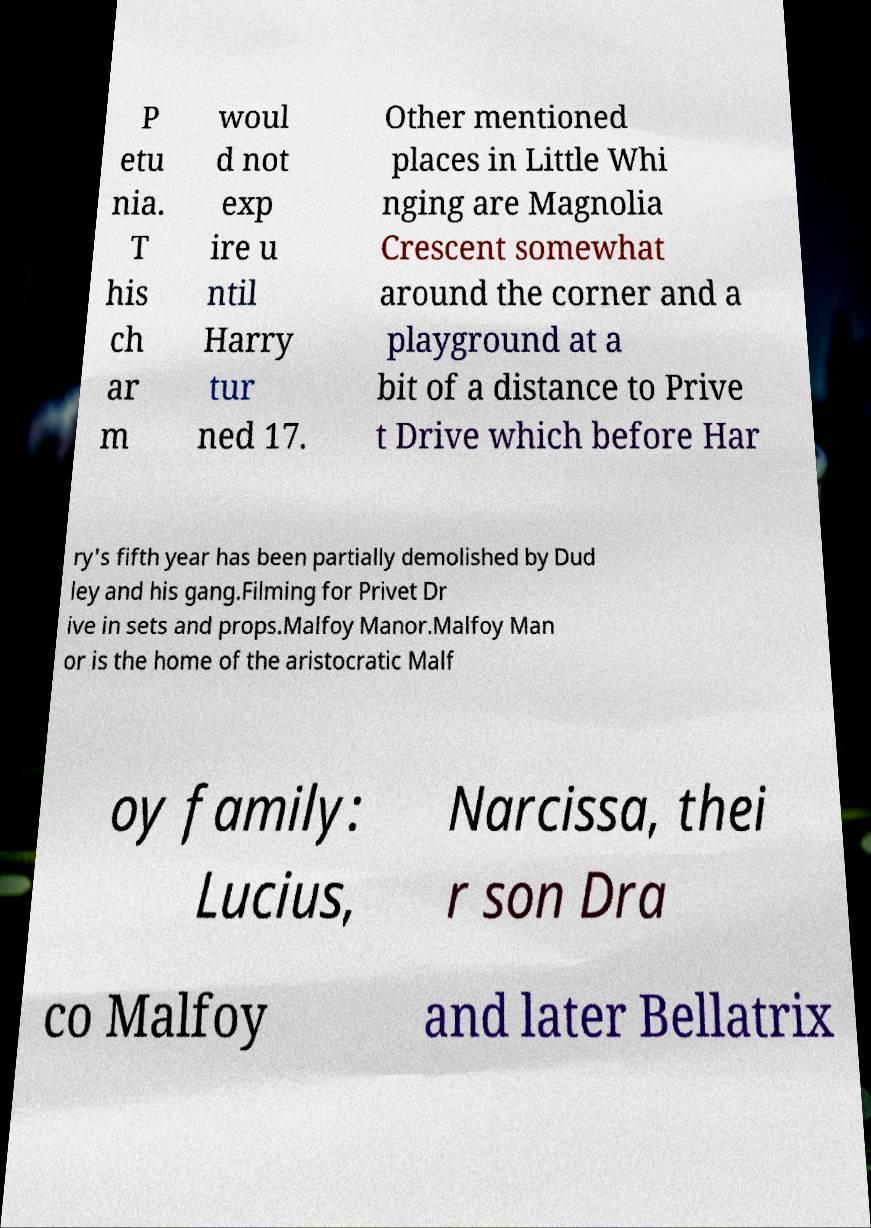There's text embedded in this image that I need extracted. Can you transcribe it verbatim? P etu nia. T his ch ar m woul d not exp ire u ntil Harry tur ned 17. Other mentioned places in Little Whi nging are Magnolia Crescent somewhat around the corner and a playground at a bit of a distance to Prive t Drive which before Har ry's fifth year has been partially demolished by Dud ley and his gang.Filming for Privet Dr ive in sets and props.Malfoy Manor.Malfoy Man or is the home of the aristocratic Malf oy family: Lucius, Narcissa, thei r son Dra co Malfoy and later Bellatrix 